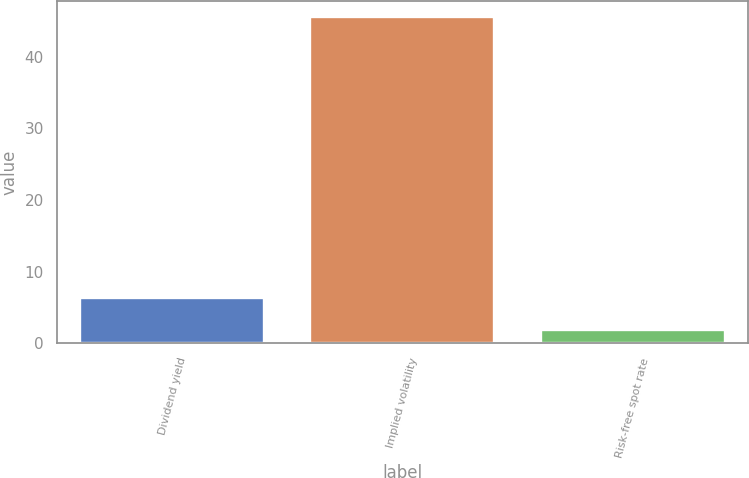Convert chart. <chart><loc_0><loc_0><loc_500><loc_500><bar_chart><fcel>Dividend yield<fcel>Implied volatility<fcel>Risk-free spot rate<nl><fcel>6.26<fcel>45.5<fcel>1.9<nl></chart> 